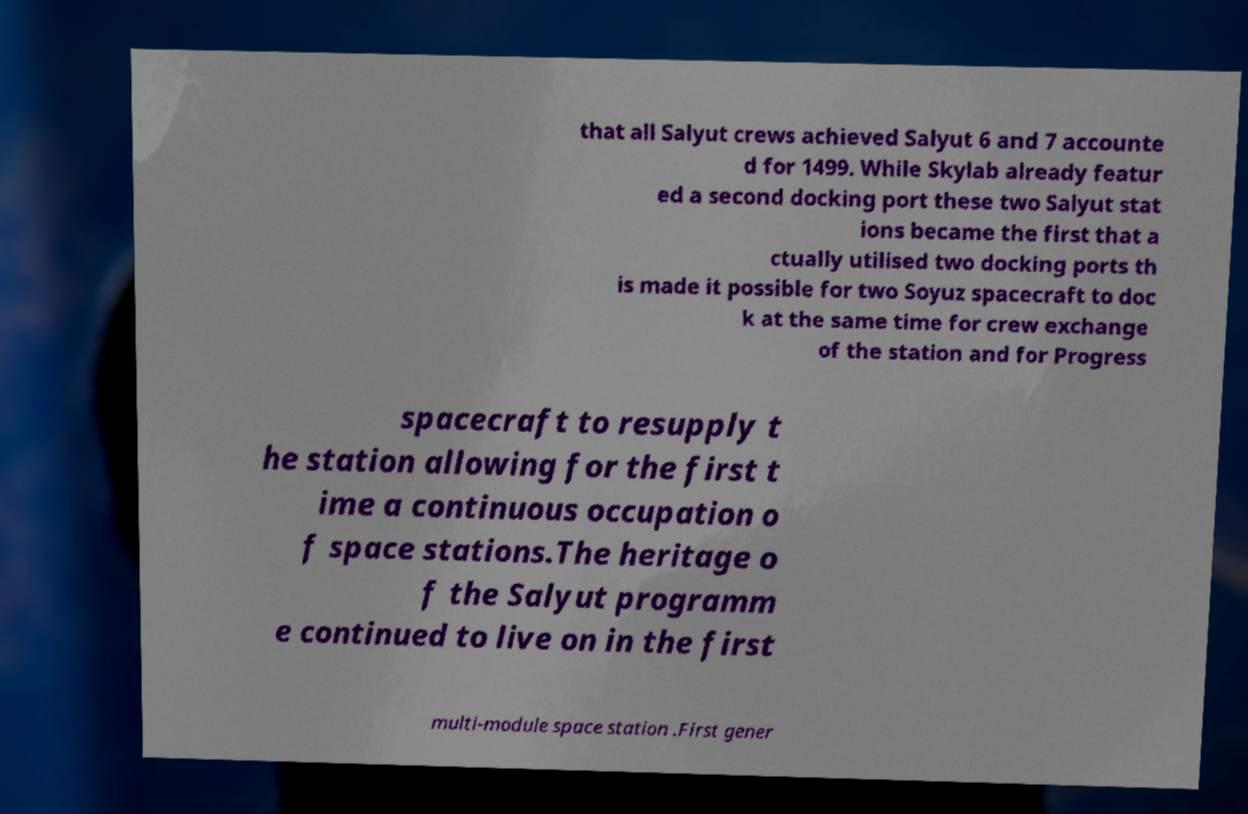I need the written content from this picture converted into text. Can you do that? that all Salyut crews achieved Salyut 6 and 7 accounte d for 1499. While Skylab already featur ed a second docking port these two Salyut stat ions became the first that a ctually utilised two docking ports th is made it possible for two Soyuz spacecraft to doc k at the same time for crew exchange of the station and for Progress spacecraft to resupply t he station allowing for the first t ime a continuous occupation o f space stations.The heritage o f the Salyut programm e continued to live on in the first multi-module space station .First gener 